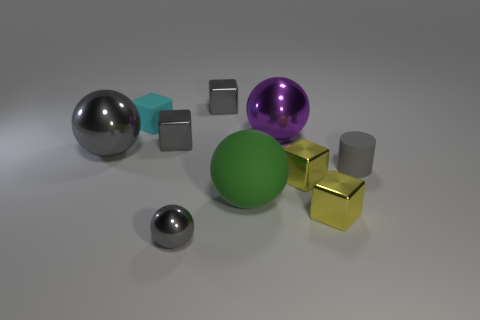There is a large ball on the right side of the large green rubber sphere; is it the same color as the small shiny cube in front of the big rubber ball?
Offer a terse response. No. Are there more large purple balls behind the large green ball than small cyan rubber things that are left of the cyan matte block?
Give a very brief answer. Yes. What is the color of the other big matte thing that is the same shape as the big purple thing?
Your answer should be compact. Green. Are there any other things that have the same shape as the cyan object?
Provide a succinct answer. Yes. There is a large gray metallic object; is it the same shape as the tiny gray thing behind the large purple metal object?
Your answer should be very brief. No. What number of other things are made of the same material as the big gray sphere?
Give a very brief answer. 6. There is a small cylinder; does it have the same color as the metallic ball that is in front of the small gray cylinder?
Ensure brevity in your answer.  Yes. There is a big ball that is in front of the small gray matte thing; what is it made of?
Make the answer very short. Rubber. Are there any big shiny objects of the same color as the tiny sphere?
Keep it short and to the point. Yes. What color is the shiny ball that is the same size as the cyan block?
Keep it short and to the point. Gray. 